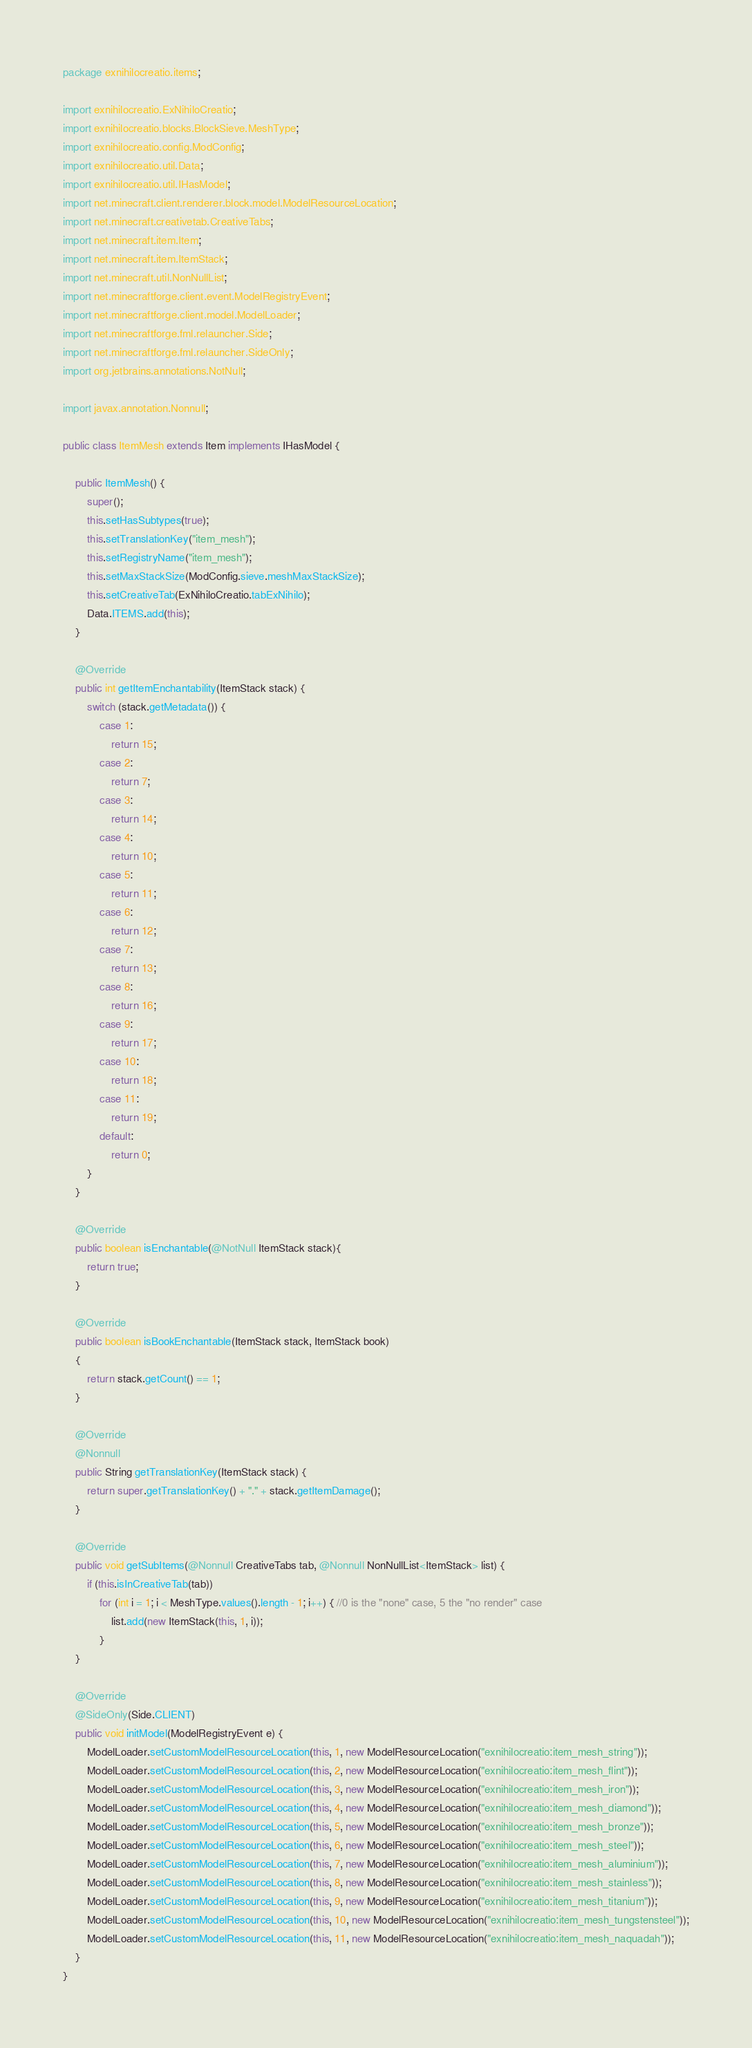Convert code to text. <code><loc_0><loc_0><loc_500><loc_500><_Java_>package exnihilocreatio.items;

import exnihilocreatio.ExNihiloCreatio;
import exnihilocreatio.blocks.BlockSieve.MeshType;
import exnihilocreatio.config.ModConfig;
import exnihilocreatio.util.Data;
import exnihilocreatio.util.IHasModel;
import net.minecraft.client.renderer.block.model.ModelResourceLocation;
import net.minecraft.creativetab.CreativeTabs;
import net.minecraft.item.Item;
import net.minecraft.item.ItemStack;
import net.minecraft.util.NonNullList;
import net.minecraftforge.client.event.ModelRegistryEvent;
import net.minecraftforge.client.model.ModelLoader;
import net.minecraftforge.fml.relauncher.Side;
import net.minecraftforge.fml.relauncher.SideOnly;
import org.jetbrains.annotations.NotNull;

import javax.annotation.Nonnull;

public class ItemMesh extends Item implements IHasModel {

    public ItemMesh() {
        super();
        this.setHasSubtypes(true);
        this.setTranslationKey("item_mesh");
        this.setRegistryName("item_mesh");
        this.setMaxStackSize(ModConfig.sieve.meshMaxStackSize);
        this.setCreativeTab(ExNihiloCreatio.tabExNihilo);
        Data.ITEMS.add(this);
    }

    @Override
    public int getItemEnchantability(ItemStack stack) {
        switch (stack.getMetadata()) {
            case 1:
                return 15;
            case 2:
                return 7;
            case 3:
                return 14;
            case 4:
                return 10;
            case 5:
                return 11;
            case 6:
                return 12;
            case 7:
                return 13;
            case 8:
                return 16;
            case 9:
                return 17;
            case 10:
                return 18;
            case 11:
                return 19;
            default:
                return 0;
        }
    }

    @Override
    public boolean isEnchantable(@NotNull ItemStack stack){
        return true;
    }

    @Override
    public boolean isBookEnchantable(ItemStack stack, ItemStack book)
    {
        return stack.getCount() == 1;
    }

    @Override
    @Nonnull
    public String getTranslationKey(ItemStack stack) {
        return super.getTranslationKey() + "." + stack.getItemDamage();
    }

    @Override
    public void getSubItems(@Nonnull CreativeTabs tab, @Nonnull NonNullList<ItemStack> list) {
        if (this.isInCreativeTab(tab))
            for (int i = 1; i < MeshType.values().length - 1; i++) { //0 is the "none" case, 5 the "no render" case
                list.add(new ItemStack(this, 1, i));
            }
    }

    @Override
    @SideOnly(Side.CLIENT)
    public void initModel(ModelRegistryEvent e) {
        ModelLoader.setCustomModelResourceLocation(this, 1, new ModelResourceLocation("exnihilocreatio:item_mesh_string"));
        ModelLoader.setCustomModelResourceLocation(this, 2, new ModelResourceLocation("exnihilocreatio:item_mesh_flint"));
        ModelLoader.setCustomModelResourceLocation(this, 3, new ModelResourceLocation("exnihilocreatio:item_mesh_iron"));
        ModelLoader.setCustomModelResourceLocation(this, 4, new ModelResourceLocation("exnihilocreatio:item_mesh_diamond"));
        ModelLoader.setCustomModelResourceLocation(this, 5, new ModelResourceLocation("exnihilocreatio:item_mesh_bronze"));
        ModelLoader.setCustomModelResourceLocation(this, 6, new ModelResourceLocation("exnihilocreatio:item_mesh_steel"));
        ModelLoader.setCustomModelResourceLocation(this, 7, new ModelResourceLocation("exnihilocreatio:item_mesh_aluminium"));
        ModelLoader.setCustomModelResourceLocation(this, 8, new ModelResourceLocation("exnihilocreatio:item_mesh_stainless"));
        ModelLoader.setCustomModelResourceLocation(this, 9, new ModelResourceLocation("exnihilocreatio:item_mesh_titanium"));
        ModelLoader.setCustomModelResourceLocation(this, 10, new ModelResourceLocation("exnihilocreatio:item_mesh_tungstensteel"));
        ModelLoader.setCustomModelResourceLocation(this, 11, new ModelResourceLocation("exnihilocreatio:item_mesh_naquadah"));
    }
}
</code> 